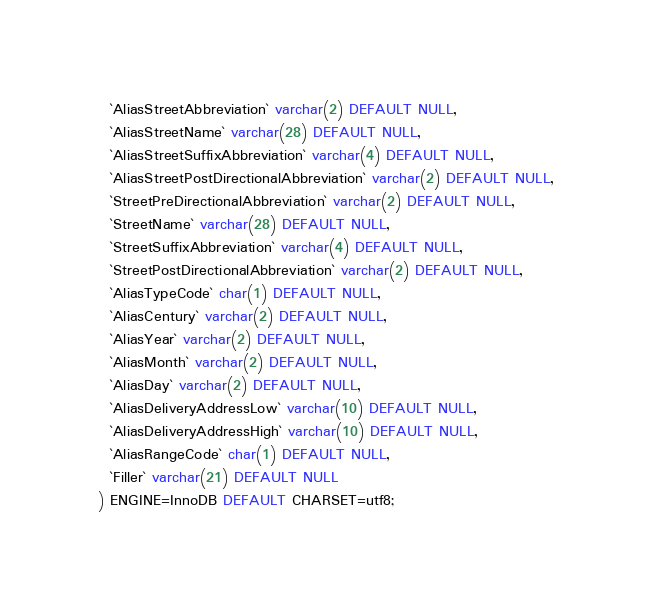Convert code to text. <code><loc_0><loc_0><loc_500><loc_500><_SQL_>  `AliasStreetAbbreviation` varchar(2) DEFAULT NULL,
  `AliasStreetName` varchar(28) DEFAULT NULL,
  `AliasStreetSuffixAbbreviation` varchar(4) DEFAULT NULL,
  `AliasStreetPostDirectionalAbbreviation` varchar(2) DEFAULT NULL,
  `StreetPreDirectionalAbbreviation` varchar(2) DEFAULT NULL,
  `StreetName` varchar(28) DEFAULT NULL,
  `StreetSuffixAbbreviation` varchar(4) DEFAULT NULL,
  `StreetPostDirectionalAbbreviation` varchar(2) DEFAULT NULL,
  `AliasTypeCode` char(1) DEFAULT NULL,
  `AliasCentury` varchar(2) DEFAULT NULL,
  `AliasYear` varchar(2) DEFAULT NULL,
  `AliasMonth` varchar(2) DEFAULT NULL,
  `AliasDay` varchar(2) DEFAULT NULL,
  `AliasDeliveryAddressLow` varchar(10) DEFAULT NULL,
  `AliasDeliveryAddressHigh` varchar(10) DEFAULT NULL,
  `AliasRangeCode` char(1) DEFAULT NULL,
  `Filler` varchar(21) DEFAULT NULL
) ENGINE=InnoDB DEFAULT CHARSET=utf8;</code> 